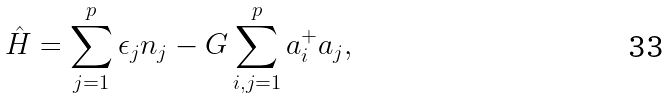<formula> <loc_0><loc_0><loc_500><loc_500>\hat { H } = \sum _ { j = 1 } ^ { p } \epsilon _ { j } n _ { j } - G \sum _ { i , j = 1 } ^ { p } a _ { i } ^ { + } a _ { j } ,</formula> 